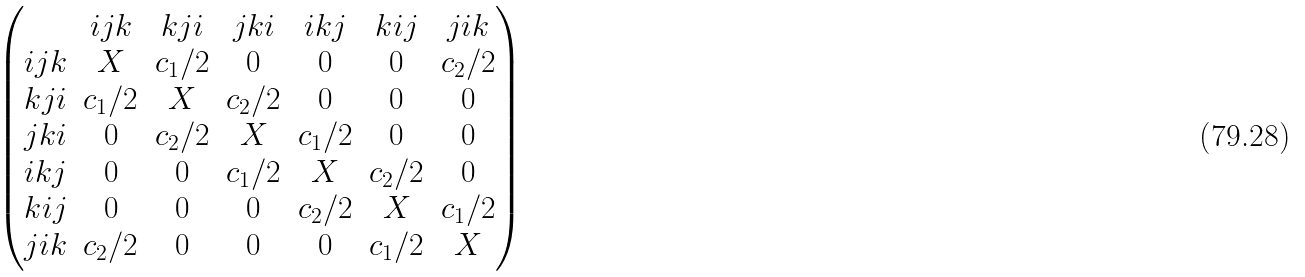<formula> <loc_0><loc_0><loc_500><loc_500>\begin{pmatrix} & i j k & k j i & j k i & i k j & k i j & j i k \\ i j k & X & c _ { 1 } / 2 & 0 & 0 & 0 & c _ { 2 } / 2 \\ k j i & c _ { 1 } / 2 & X & c _ { 2 } / 2 & 0 & 0 & 0 \\ j k i & 0 & c _ { 2 } / 2 & X & c _ { 1 } / 2 & 0 & 0 \\ i k j & 0 & 0 & c _ { 1 } / 2 & X & c _ { 2 } / 2 & 0 \\ k i j & 0 & 0 & 0 & c _ { 2 } / 2 & X & c _ { 1 } / 2 \\ j i k & c _ { 2 } / 2 & 0 & 0 & 0 & c _ { 1 } / 2 & X \end{pmatrix}</formula> 